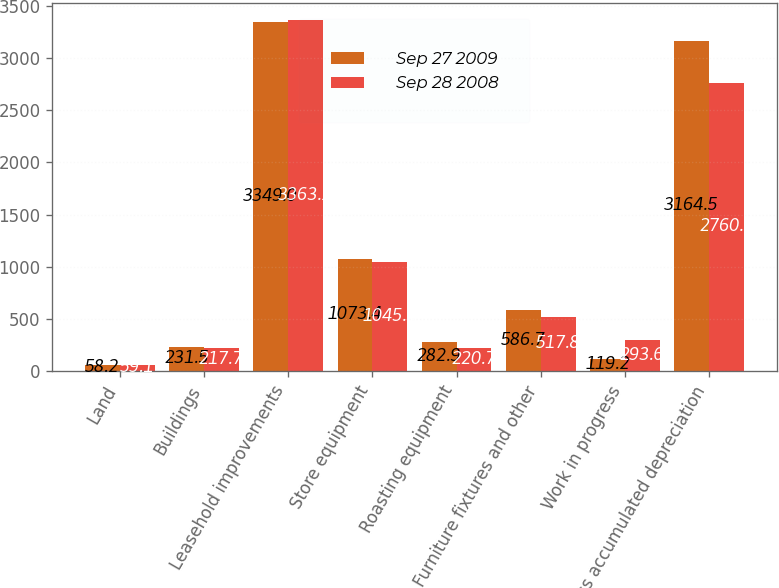Convert chart. <chart><loc_0><loc_0><loc_500><loc_500><stacked_bar_chart><ecel><fcel>Land<fcel>Buildings<fcel>Leasehold improvements<fcel>Store equipment<fcel>Roasting equipment<fcel>Furniture fixtures and other<fcel>Work in progress<fcel>Less accumulated depreciation<nl><fcel>Sep 27 2009<fcel>58.2<fcel>231.5<fcel>3349<fcel>1073.4<fcel>282.9<fcel>586.7<fcel>119.2<fcel>3164.5<nl><fcel>Sep 28 2008<fcel>59.1<fcel>217.7<fcel>3363.1<fcel>1045.3<fcel>220.7<fcel>517.8<fcel>293.6<fcel>2760.9<nl></chart> 